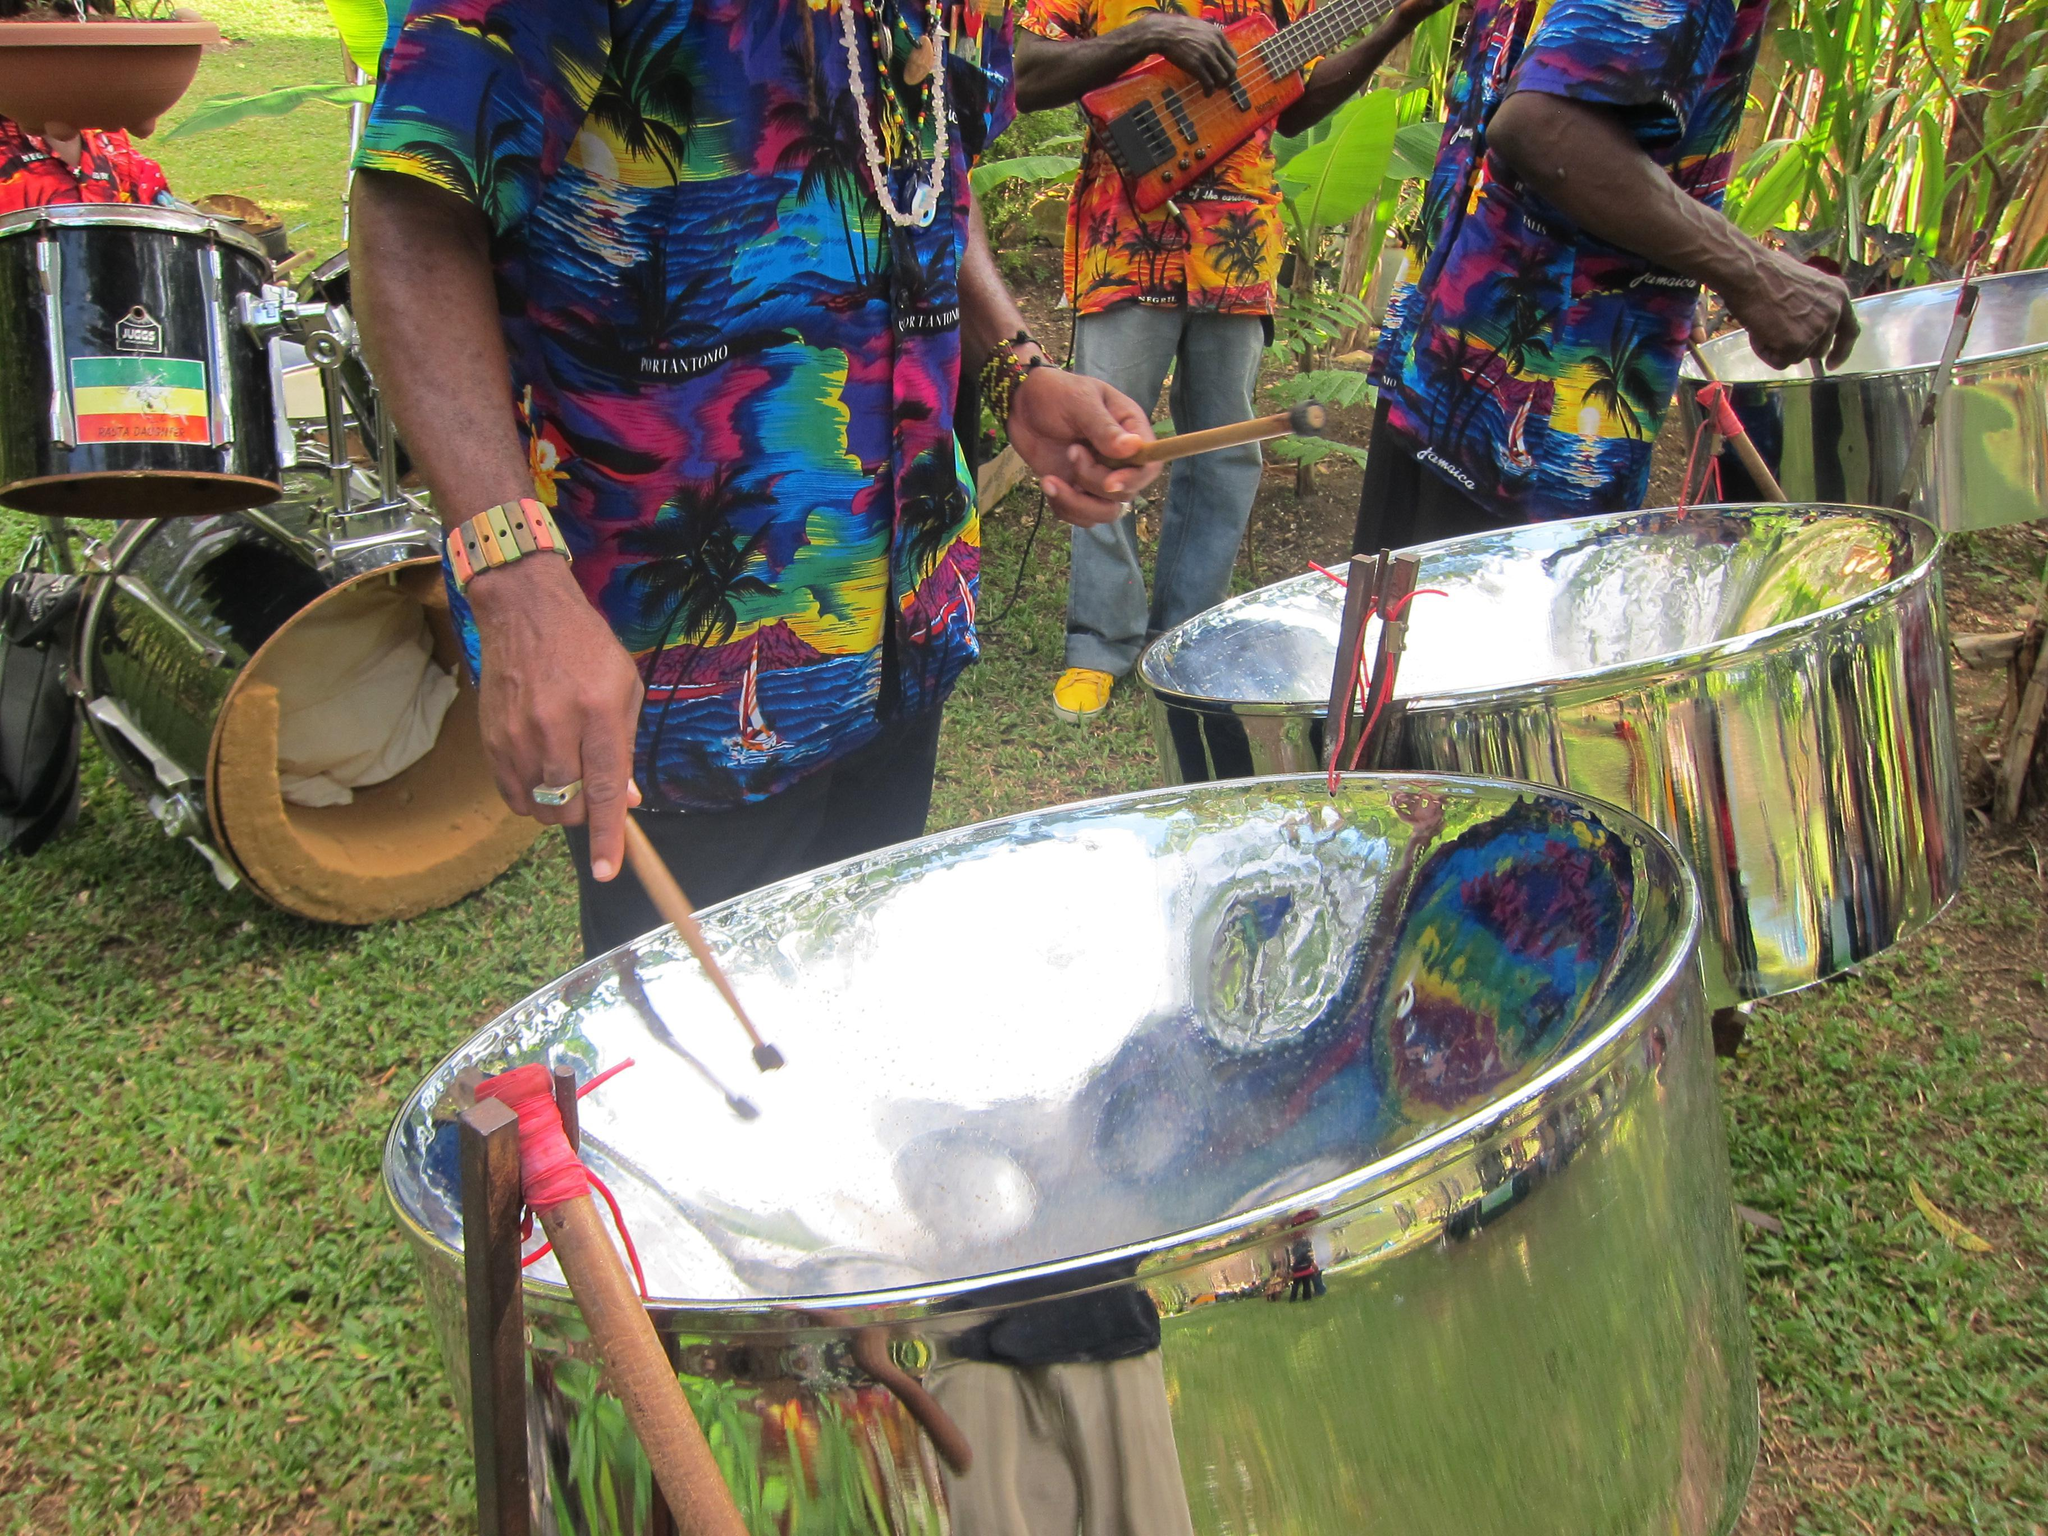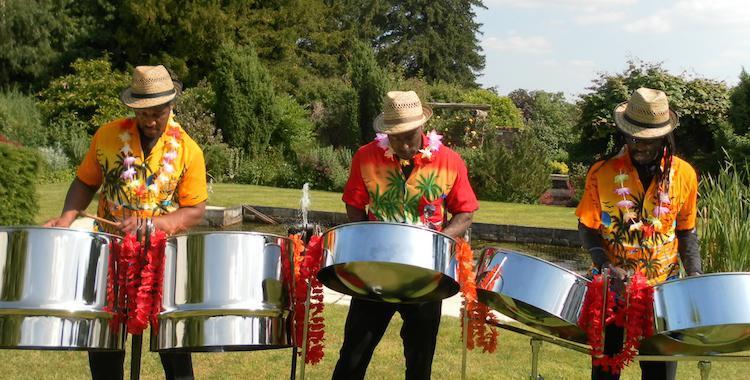The first image is the image on the left, the second image is the image on the right. Assess this claim about the two images: "In one image all the musicians are wearing hats.". Correct or not? Answer yes or no. Yes. The first image is the image on the left, the second image is the image on the right. For the images shown, is this caption "One image features three men in hats and leis and hawaiian shirts standing behind silver metal drums on pivoting stands." true? Answer yes or no. Yes. 